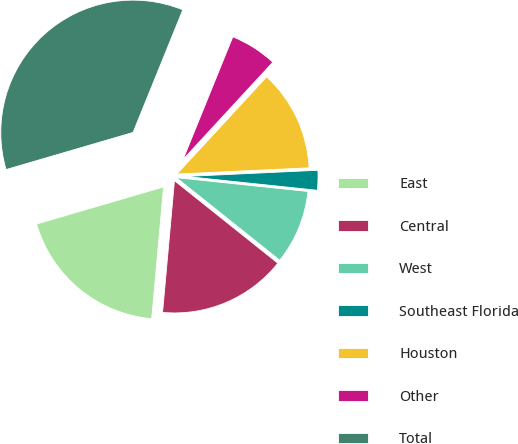<chart> <loc_0><loc_0><loc_500><loc_500><pie_chart><fcel>East<fcel>Central<fcel>West<fcel>Southeast Florida<fcel>Houston<fcel>Other<fcel>Total<nl><fcel>19.04%<fcel>15.71%<fcel>9.06%<fcel>2.41%<fcel>12.39%<fcel>5.73%<fcel>35.66%<nl></chart> 